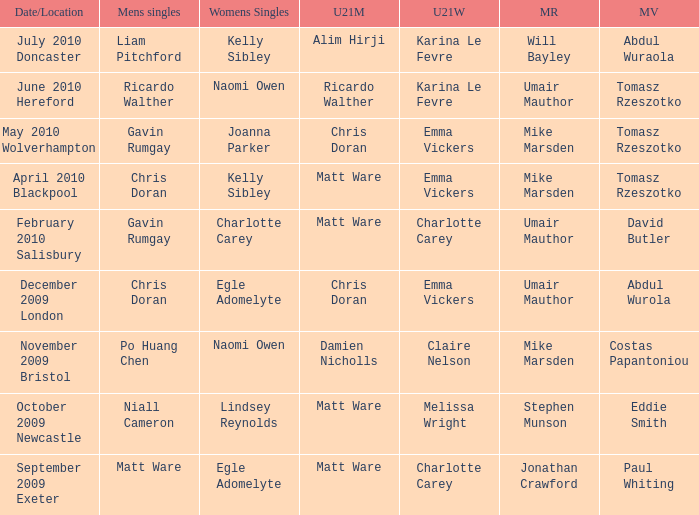When Paul Whiting won the mixed veteran, who won the mixed restricted? Jonathan Crawford. 